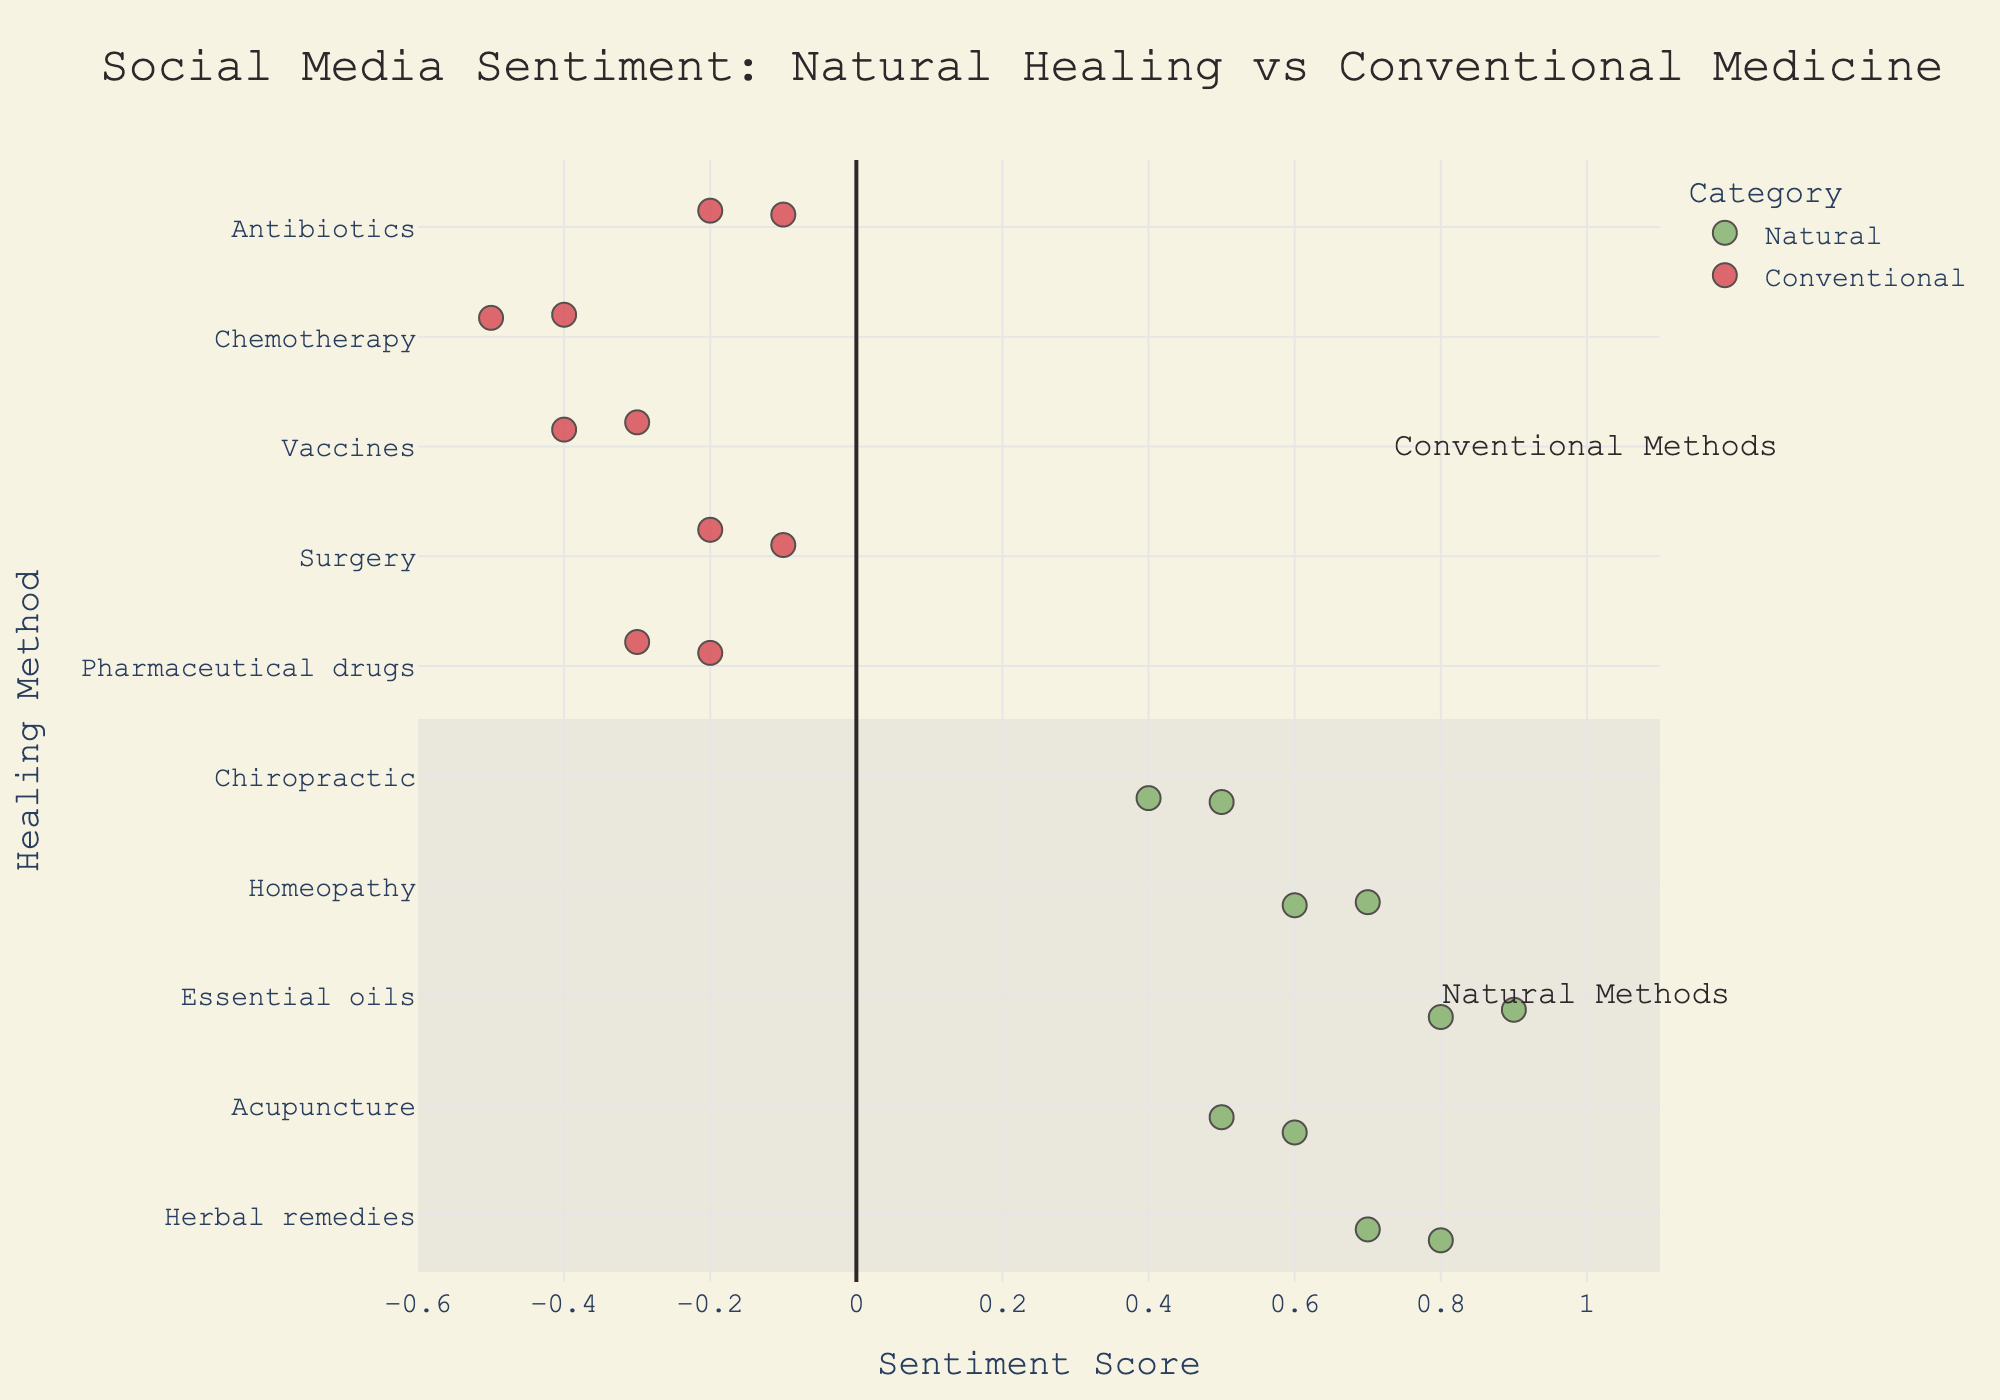What is the title of the plot? The title is prominently displayed at the top of the figure. It reads "Social Media Sentiment: Natural Healing vs Conventional Medicine."
Answer: Social Media Sentiment: Natural Healing vs Conventional Medicine Which natural healing method has the highest sentiment score, and on which platform is it found? By observing the points representing the natural methods, Essential oils on Instagram has the highest sentiment score of 0.9.
Answer: Essential oils, Instagram How many conventional methods have negative sentiment scores? By counting the points in the conventional category that fall below the 0 sentiment mark, there are six conventional methods with negative sentiment scores.
Answer: 6 What's the average sentiment score for Acupuncture across all platforms? The sentiment scores for Acupuncture are 0.6, and 0.5. Adding these together, we get 1.1. Dividing by the number of points (2) gives us an average of 0.55.
Answer: 0.55 Compare the sentiment score of Homeopathy across Twitter and Instagram. Which platform has a higher sentiment for this method? Homeopathy on Twitter has a sentiment score of 0.7, while on Instagram, it is 0.6. Thus, Twitter has a higher sentiment for Homeopathy.
Answer: Twitter What is the sentiment score range for natural methods? The lowest sentiment score among natural methods is for Chiropractic at 0.4, and the highest is for Essential oils at 0.9. So the range is 0.9 - 0.4 = 0.5.
Answer: 0.5 Which platform shows the lowest sentiment score for vaccines? By looking at the points for vaccines, Instagram has a sentiment score of -0.3, while Twitter has -0.4. Hence, Twitter shows the lowest sentiment score for vaccines.
Answer: Twitter How does the sentiment score of Herbal remedies on Twitter compare to Pharmaceuticals on Twitter? Herbal remedies on Twitter have a sentiment score of 0.8, while Pharmaceuticals on Twitter have a score of -0.2. Herbal remedies have a higher sentiment on Twitter.
Answer: Herbal remedies What's the overall sentiment trend for surgical methods compared to homeopathic methods? Surgical methods like Surgery and Chemotherapy have negatively skewed sentiment scores, whereas homeopathic methods like Homeopathy and Essential oils have more positive sentiment scores, indicating a trend of more positive sentiment towards homeopathic methods.
Answer: More positive for homeopathic methods Is there a distinguishable difference in sentiment between natural and conventional methods based on social media posts? By observing the color-coded categories, natural methods predominantly exhibit positive sentiment scores, while conventional methods generally show negative sentiment scores. This suggests a significant difference in sentiment between the two categories.
Answer: Yes 